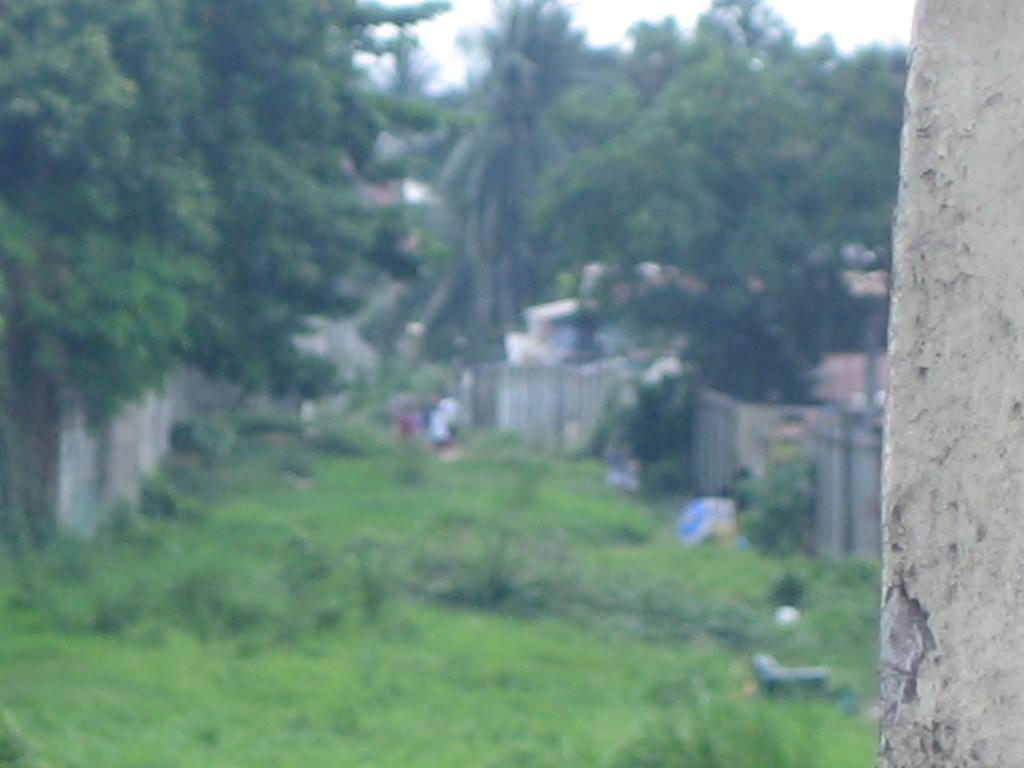How would you summarize this image in a sentence or two? In the foreground of this image, on the right it seems like a tree trunk. In the blur background, we can see trees, grass, wall, few objects, houses and the sky. 